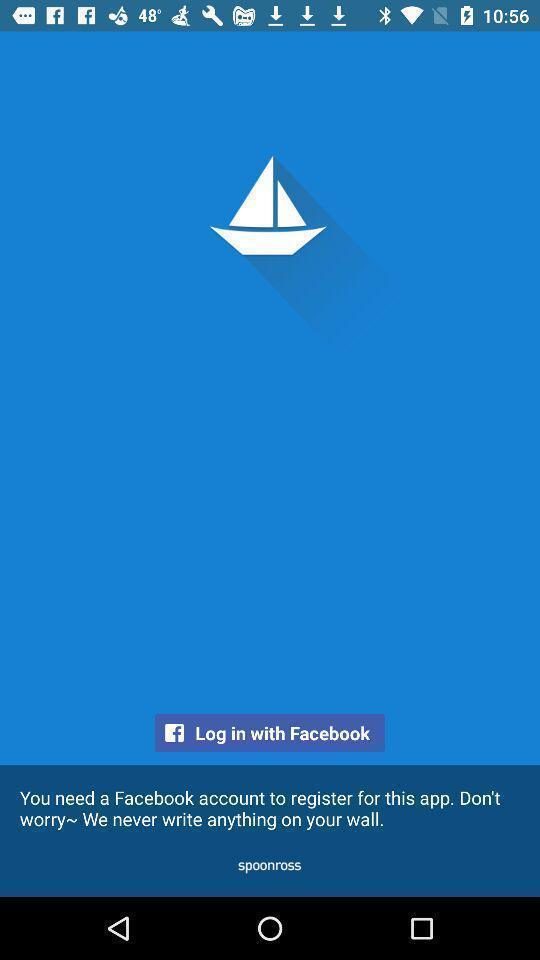Tell me what you see in this picture. Screen showing login with social application. 